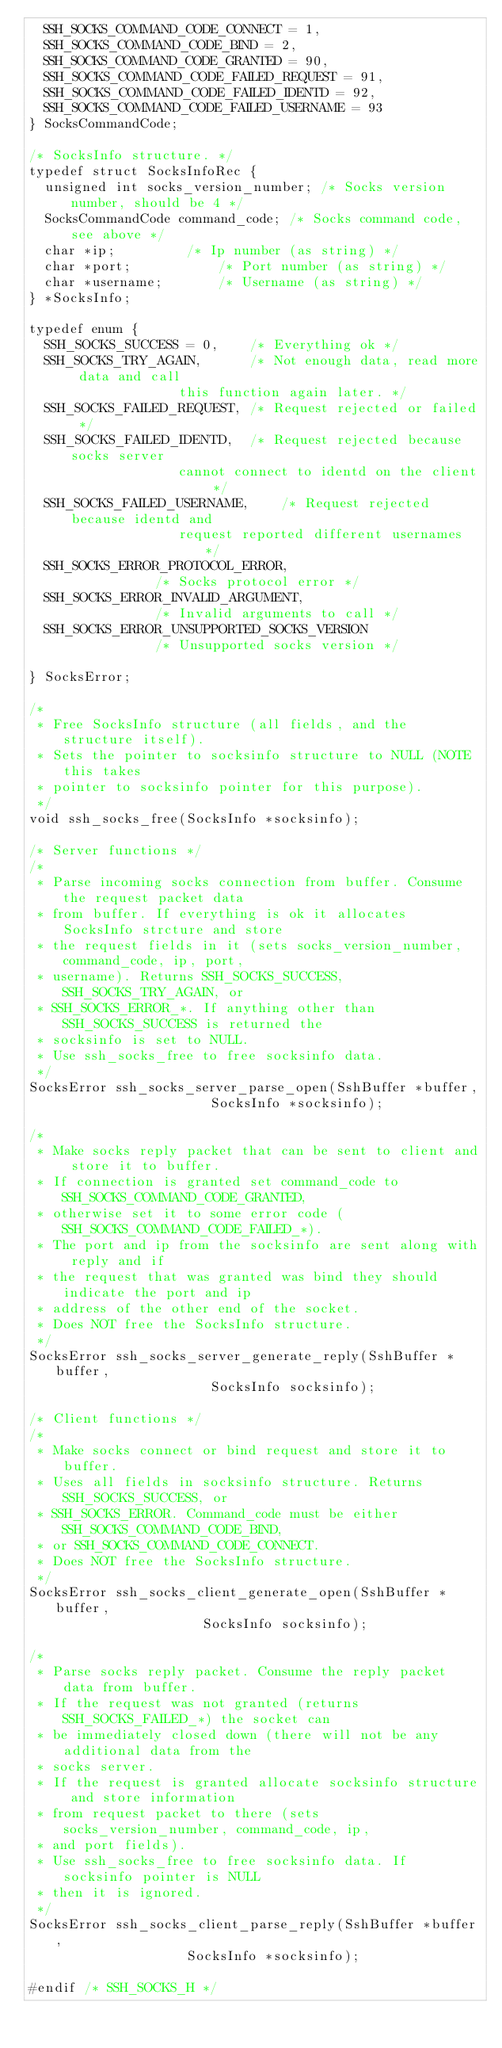<code> <loc_0><loc_0><loc_500><loc_500><_C_>  SSH_SOCKS_COMMAND_CODE_CONNECT = 1,
  SSH_SOCKS_COMMAND_CODE_BIND = 2,
  SSH_SOCKS_COMMAND_CODE_GRANTED = 90,
  SSH_SOCKS_COMMAND_CODE_FAILED_REQUEST = 91,
  SSH_SOCKS_COMMAND_CODE_FAILED_IDENTD = 92,
  SSH_SOCKS_COMMAND_CODE_FAILED_USERNAME = 93
} SocksCommandCode;

/* SocksInfo structure. */
typedef struct SocksInfoRec {
  unsigned int socks_version_number; /* Socks version number, should be 4 */
  SocksCommandCode command_code; /* Socks command code, see above */
  char *ip;			/* Ip number (as string) */
  char *port;			/* Port number (as string) */
  char *username;		/* Username (as string) */
} *SocksInfo;

typedef enum {
  SSH_SOCKS_SUCCESS = 0,	/* Everything ok */
  SSH_SOCKS_TRY_AGAIN,		/* Not enough data, read more data and call
				   this function again later. */
  SSH_SOCKS_FAILED_REQUEST,	/* Request rejected or failed */
  SSH_SOCKS_FAILED_IDENTD,	/* Request rejected because socks server
				   cannot connect to identd on the client */
  SSH_SOCKS_FAILED_USERNAME,	/* Request rejected because identd and
				   request reported different usernames */
  SSH_SOCKS_ERROR_PROTOCOL_ERROR,
				/* Socks protocol error */
  SSH_SOCKS_ERROR_INVALID_ARGUMENT,
				/* Invalid arguments to call */
  SSH_SOCKS_ERROR_UNSUPPORTED_SOCKS_VERSION
				/* Unsupported socks version */

} SocksError;

/*
 * Free SocksInfo structure (all fields, and the structure itself).
 * Sets the pointer to socksinfo structure to NULL (NOTE this takes
 * pointer to socksinfo pointer for this purpose). 
 */
void ssh_socks_free(SocksInfo *socksinfo);

/* Server functions */
/*
 * Parse incoming socks connection from buffer. Consume the request packet data
 * from buffer. If everything is ok it allocates SocksInfo strcture and store
 * the request fields in it (sets socks_version_number, command_code, ip, port,
 * username). Returns SSH_SOCKS_SUCCESS, SSH_SOCKS_TRY_AGAIN, or
 * SSH_SOCKS_ERROR_*. If anything other than SSH_SOCKS_SUCCESS is returned the
 * socksinfo is set to NULL.
 * Use ssh_socks_free to free socksinfo data.
 */
SocksError ssh_socks_server_parse_open(SshBuffer *buffer,
				       SocksInfo *socksinfo);

/*
 * Make socks reply packet that can be sent to client and store it to buffer.
 * If connection is granted set command_code to SSH_SOCKS_COMMAND_CODE_GRANTED,
 * otherwise set it to some error code (SSH_SOCKS_COMMAND_CODE_FAILED_*).
 * The port and ip from the socksinfo are sent along with reply and if
 * the request that was granted was bind they should indicate the port and ip
 * address of the other end of the socket. 
 * Does NOT free the SocksInfo structure.
 */
SocksError ssh_socks_server_generate_reply(SshBuffer *buffer,
					   SocksInfo socksinfo);

/* Client functions */
/*
 * Make socks connect or bind request and store it to buffer.
 * Uses all fields in socksinfo structure. Returns SSH_SOCKS_SUCCESS, or
 * SSH_SOCKS_ERROR. Command_code must be either SSH_SOCKS_COMMAND_CODE_BIND,
 * or SSH_SOCKS_COMMAND_CODE_CONNECT. 
 * Does NOT free the SocksInfo structure.
 */
SocksError ssh_socks_client_generate_open(SshBuffer *buffer,
					  SocksInfo socksinfo);

/*
 * Parse socks reply packet. Consume the reply packet data from buffer.
 * If the request was not granted (returns SSH_SOCKS_FAILED_*) the socket can
 * be immediately closed down (there will not be any additional data from the
 * socks server.
 * If the request is granted allocate socksinfo structure and store information
 * from request packet to there (sets socks_version_number, command_code, ip,
 * and port fields).
 * Use ssh_socks_free to free socksinfo data. If socksinfo pointer is NULL
 * then it is ignored. 
 */
SocksError ssh_socks_client_parse_reply(SshBuffer *buffer,
					SocksInfo *socksinfo);

#endif /* SSH_SOCKS_H */
</code> 